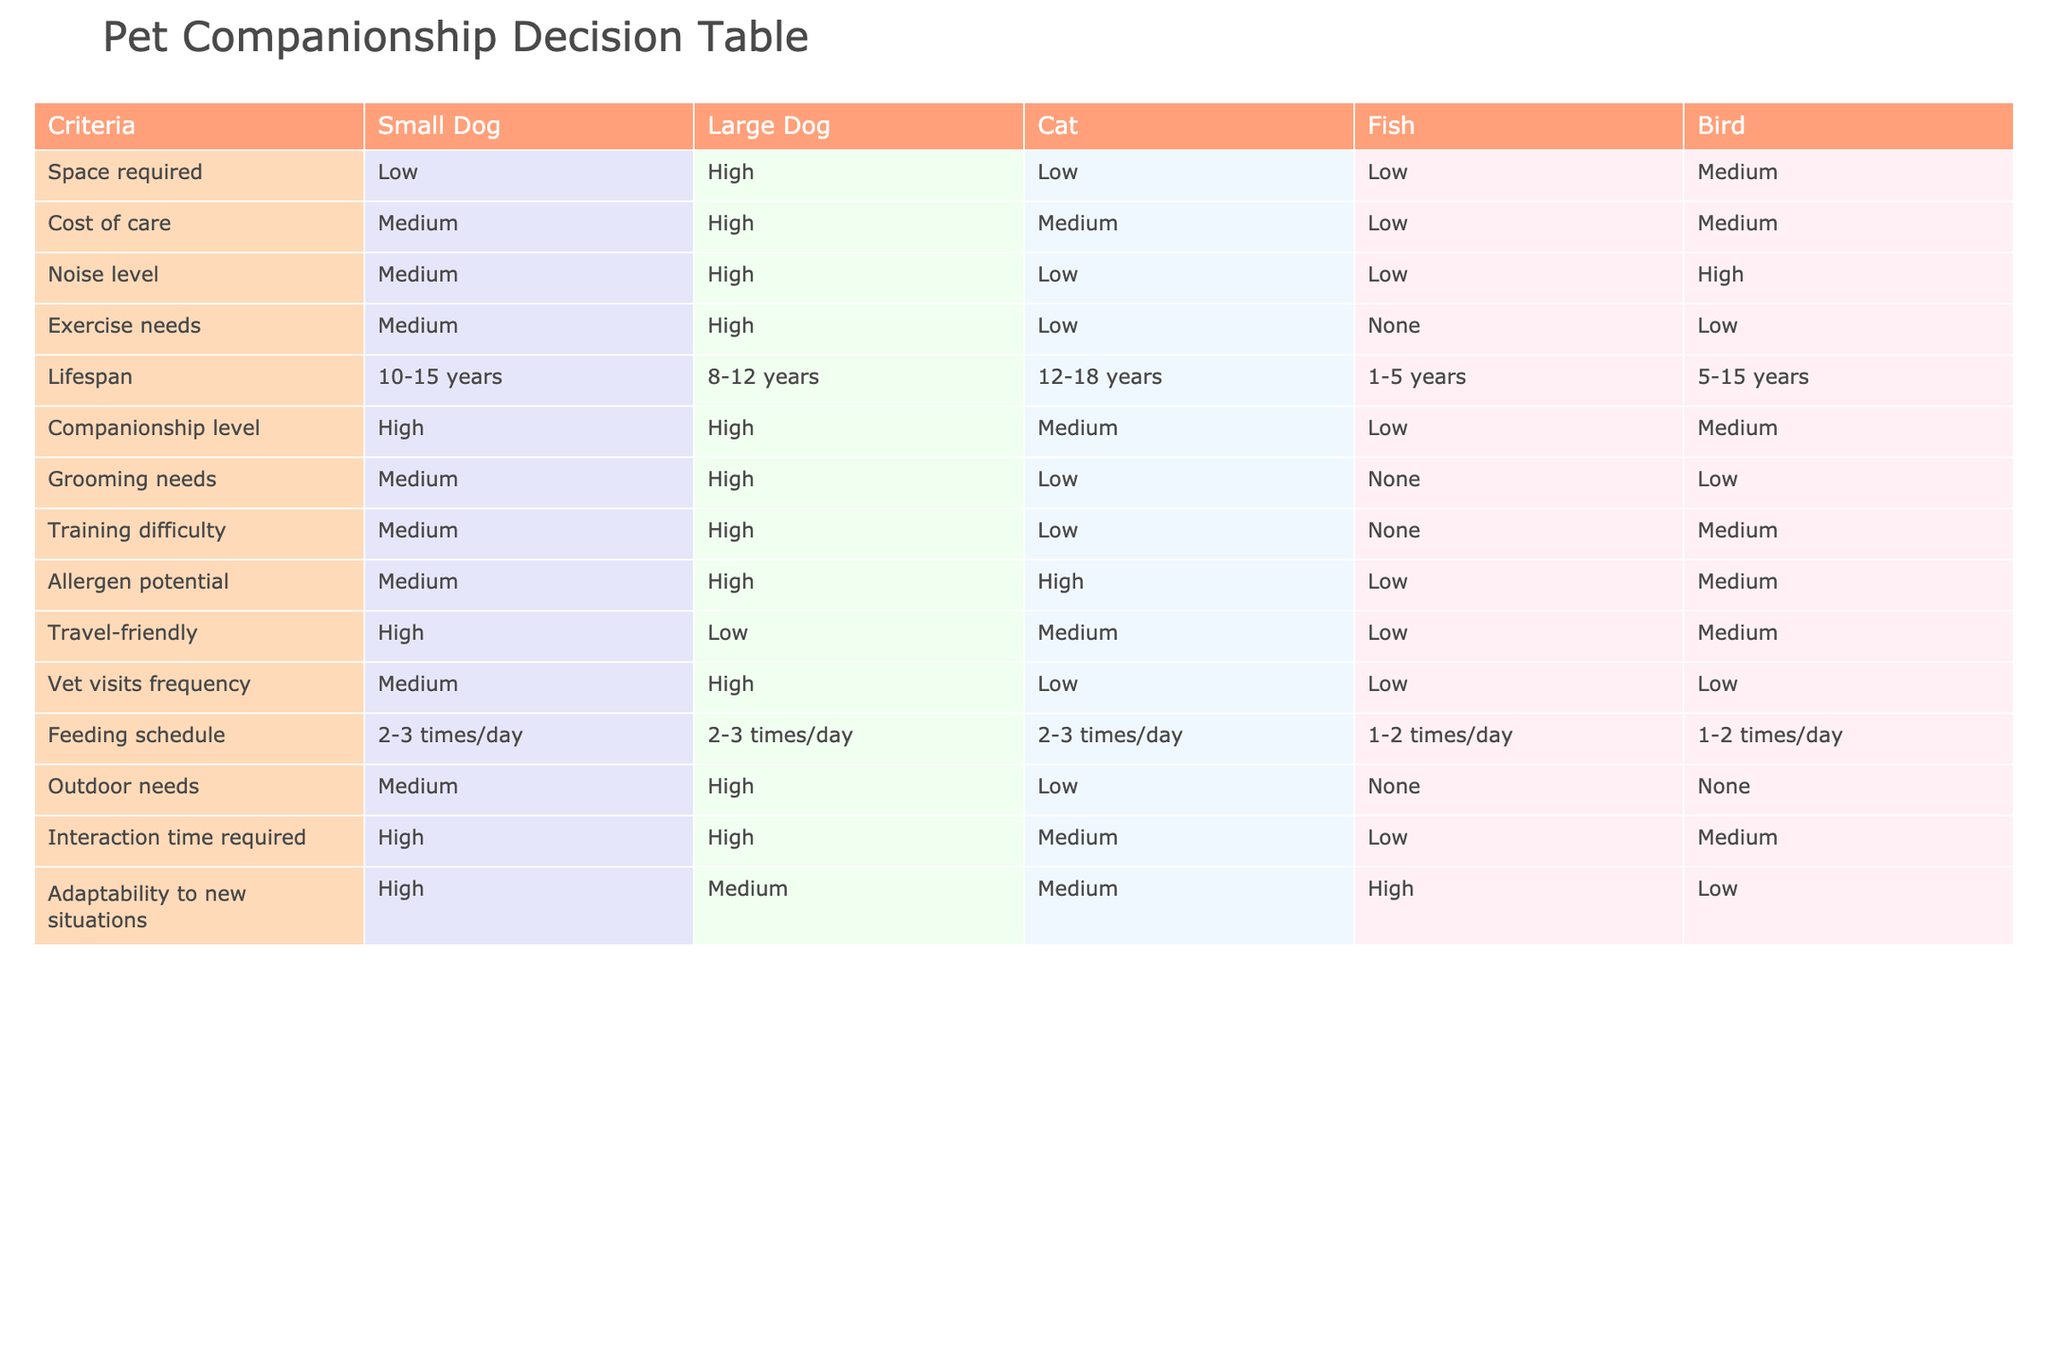What is the space requirement for a large dog? The table indicates that the space required for a large dog is classified as "High."
Answer: High What is the cost of care for a cat compared to a fish? The table shows that the cost of care for a cat is "Medium," while it is "Low" for a fish. Comparing these two, the cat costs more.
Answer: Cat costs more How many times a day does a bird need to be fed? According to the table, a bird needs to be fed "1-2 times/day."
Answer: 1-2 times/day Is the allergen potential of small dogs higher than that of cats? The allergen potential for small dogs is "Medium" while for cats it is "High." Since Medium is lower than High, the statement is false.
Answer: No What is the average lifespan of a fish and a bird combined? The lifespan for a fish is indicated as "1-5 years" and for a bird as "5-15 years." The average lifespan is calculated by taking the midpoints: fish ~3 years, bird ~10 years. So, (3 + 10) / 2 = 6.5 years.
Answer: 6.5 years Which pet has the highest companionship level? Both small dogs and large dogs have the highest companionship level rated as "High" in the table.
Answer: Small and large dogs Do large dogs require more exercise compared to small dogs? The table indicates that large dogs have "High" exercise needs whereas small dogs have "Medium." Therefore, large dogs require more exercise.
Answer: Yes What are the outdoor needs for cats and fish? The table shows that cats have "Low" outdoor needs, while fish have "None." Comparing these values, both require minimal to no outdoor needs, but fish require none at all.
Answer: None for fish Which pet is the most travel-friendly? The table states that small dogs are classified as "High" in travel-friendliness compared to all other options.
Answer: Small dog 